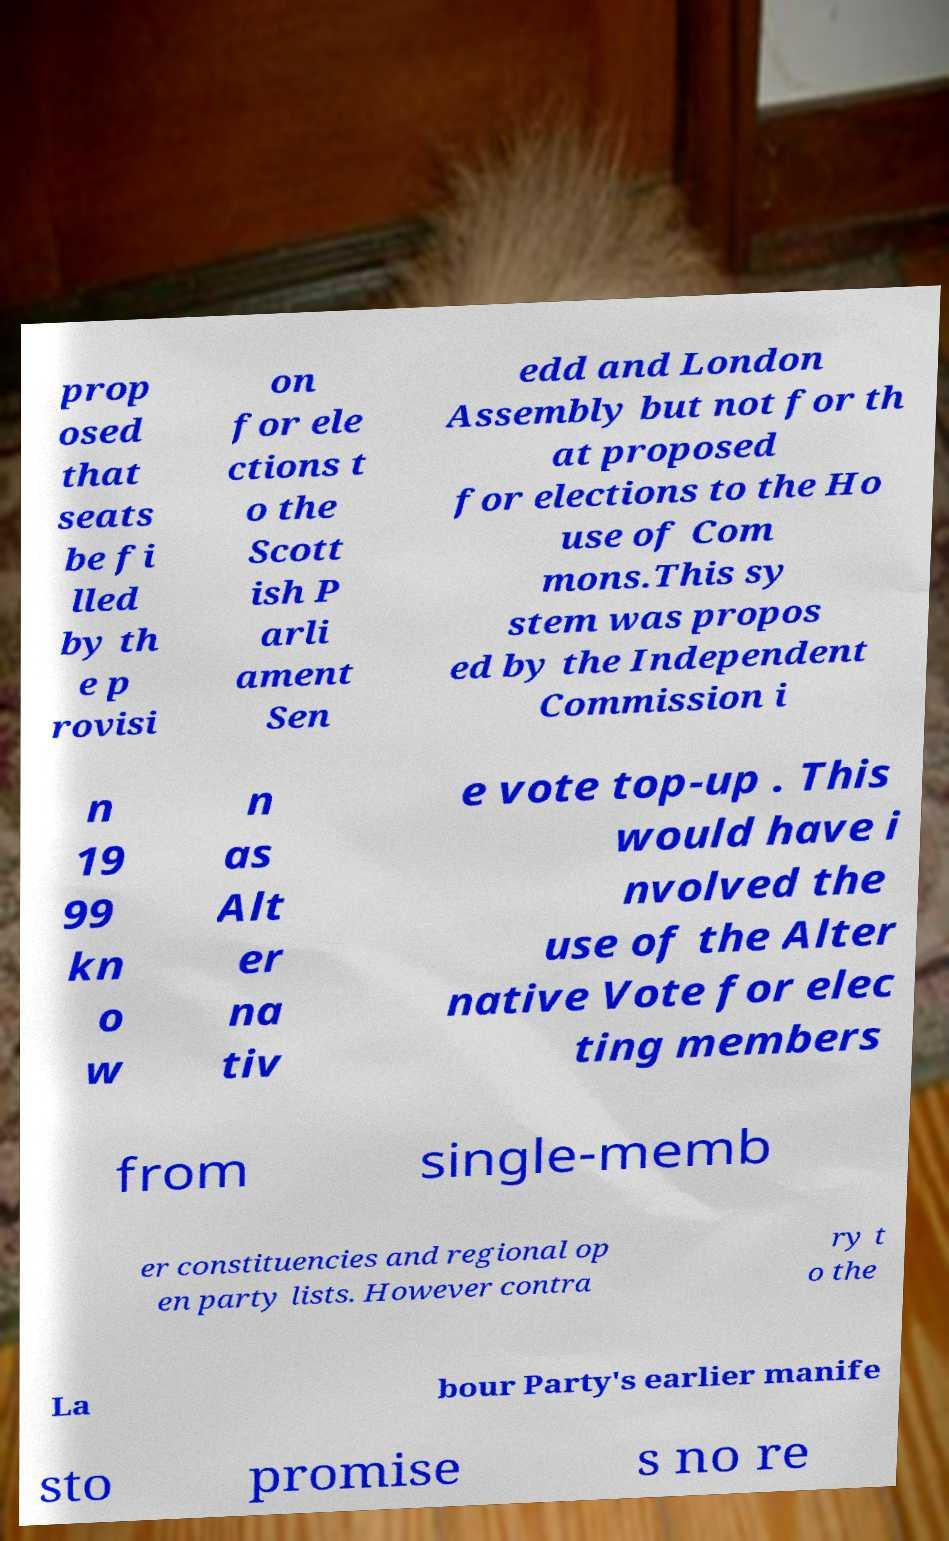Please read and relay the text visible in this image. What does it say? prop osed that seats be fi lled by th e p rovisi on for ele ctions t o the Scott ish P arli ament Sen edd and London Assembly but not for th at proposed for elections to the Ho use of Com mons.This sy stem was propos ed by the Independent Commission i n 19 99 kn o w n as Alt er na tiv e vote top-up . This would have i nvolved the use of the Alter native Vote for elec ting members from single-memb er constituencies and regional op en party lists. However contra ry t o the La bour Party's earlier manife sto promise s no re 